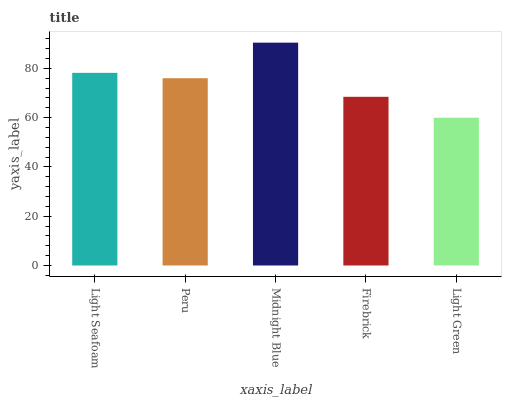Is Light Green the minimum?
Answer yes or no. Yes. Is Midnight Blue the maximum?
Answer yes or no. Yes. Is Peru the minimum?
Answer yes or no. No. Is Peru the maximum?
Answer yes or no. No. Is Light Seafoam greater than Peru?
Answer yes or no. Yes. Is Peru less than Light Seafoam?
Answer yes or no. Yes. Is Peru greater than Light Seafoam?
Answer yes or no. No. Is Light Seafoam less than Peru?
Answer yes or no. No. Is Peru the high median?
Answer yes or no. Yes. Is Peru the low median?
Answer yes or no. Yes. Is Light Green the high median?
Answer yes or no. No. Is Firebrick the low median?
Answer yes or no. No. 